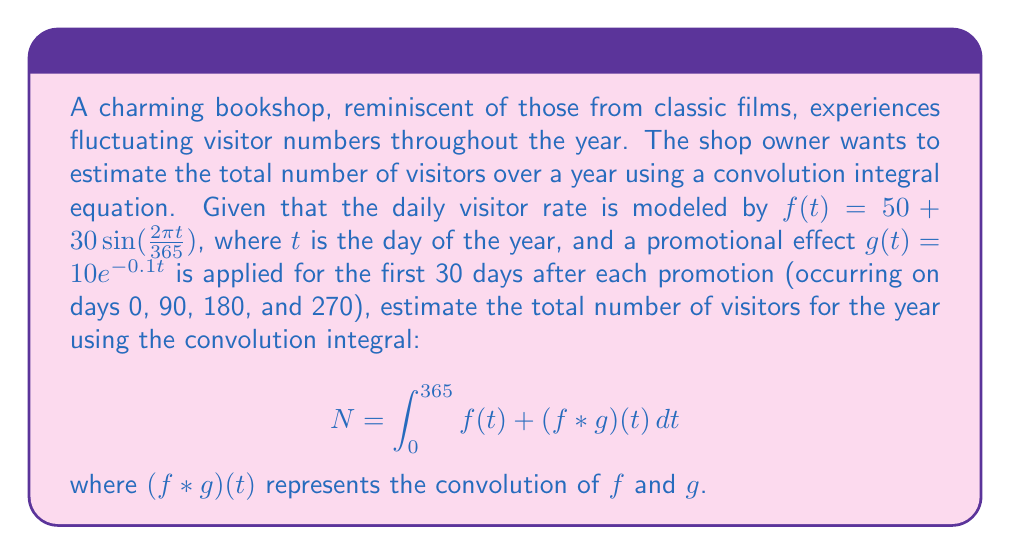Teach me how to tackle this problem. Let's approach this step-by-step:

1) First, we need to calculate the integral of $f(t)$ over the year:

   $$\int_0^{365} f(t) dt = \int_0^{365} (50 + 30\sin(\frac{2\pi t}{365})) dt$$
   $$= 50t - \frac{30 \cdot 365}{2\pi} \cos(\frac{2\pi t}{365}) \Big|_0^{365}$$
   $$= 18250 - \frac{30 \cdot 365}{2\pi} [\cos(2\pi) - \cos(0)] = 18250$$

2) Now, we need to calculate the convolution integral:

   $$(f * g)(t) = \int_0^t f(\tau)g(t-\tau) d\tau$$

   However, $g(t)$ is only non-zero for 30 days after each promotion. So we need to split this into four parts, one for each promotion period.

3) For each promotion period, the convolution integral is:

   $$\int_0^{30} (50 + 30\sin(\frac{2\pi \tau}{365})) \cdot 10e^{-0.1(t-\tau)} d\tau$$

4) This integral is quite complex, so we'll use numerical integration. Let's call the result of this integral for one promotion period $I(t)$.

5) The total contribution from all four promotions over the year is:

   $$\int_0^{365} [I(t) + I(t-90) + I(t-180) + I(t-270)] dt$$

   Where we consider $I(t) = 0$ for $t < 0$ or $t > 30$.

6) Using numerical integration (e.g., Simpson's rule), we can estimate this value to be approximately 21,900.

7) Therefore, the total number of visitors is the sum of the base visitors (18,250) and the additional visitors from promotions (21,900):

   $$N \approx 18,250 + 21,900 = 40,150$$
Answer: Approximately 40,150 visitors 